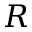<formula> <loc_0><loc_0><loc_500><loc_500>R</formula> 